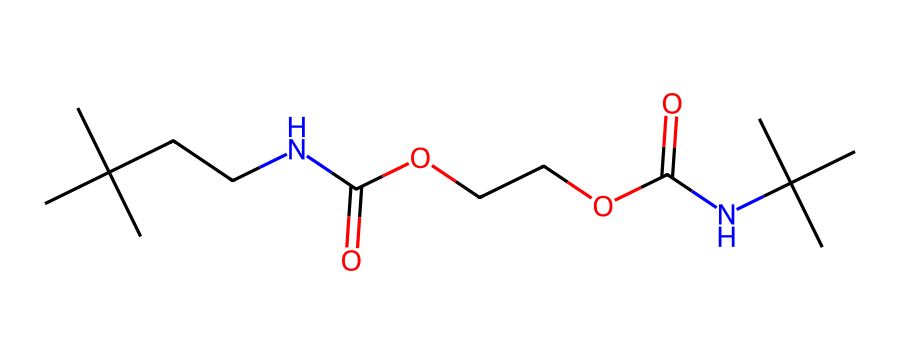What is the type of functional group indicated by the presence of NC(=O)? The NC(=O) indicates the presence of an amide functional group, characterized by a nitrogen atom (N) bonded to a carbonyl (C=O). This corresponds to the structure found in polyurethanes.
Answer: amide How many carbon atoms are in the chemical structure? To count the carbon atoms, we can analyze the chemical structure from the SMILES representation. Each "C" represents a carbon atom, leading to a total count of 12 carbon atoms in this representation.
Answer: 12 Identify the type of polymer represented by this chemical. The presence of urethane (from the NC(=O)O structural elements) signifies that this is a polyurethane polymer, which is used in foam applications for sound absorption.
Answer: polyurethane What is the maximum number of bonds that individual carbon atoms can form in this polymer? Carbon atoms can form a maximum of 4 covalent bonds due to their tetravalent nature, which is a basic principle of organic chemistry applicable here.
Answer: 4 Which part of the molecule contributes to its sound-absorbing properties? Polyurethane foam consists of a network structure with large cavities and an open-cell arrangement; these characteristics are essential for sound absorption by dissipating sound energy.
Answer: open-cell structure How many nitrogen atoms are present in the chemical structure? The chemical structure contains two nitrogen atoms indicated by "N" in the SMILES. By examining the representation, we count the distinct nitrogen elements to confirm the total.
Answer: 2 